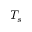Convert formula to latex. <formula><loc_0><loc_0><loc_500><loc_500>T _ { s }</formula> 